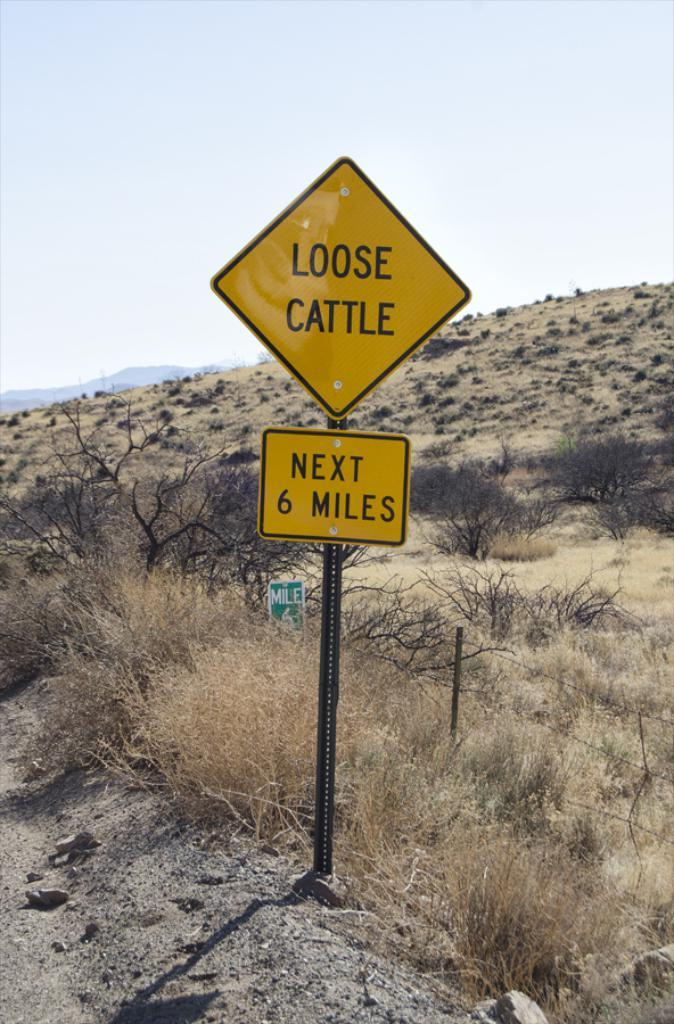<image>
Render a clear and concise summary of the photo. the words loose cattle that are on a sign 